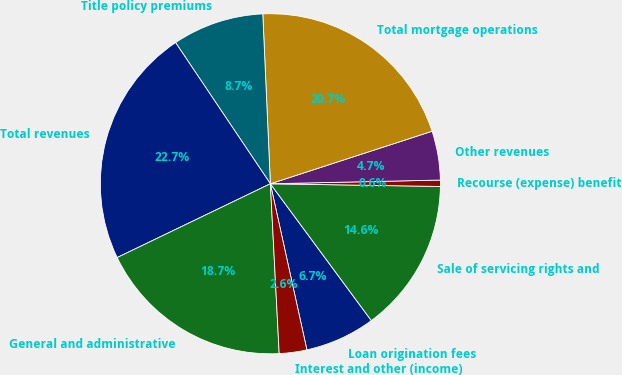Convert chart. <chart><loc_0><loc_0><loc_500><loc_500><pie_chart><fcel>Loan origination fees<fcel>Sale of servicing rights and<fcel>Recourse (expense) benefit<fcel>Other revenues<fcel>Total mortgage operations<fcel>Title policy premiums<fcel>Total revenues<fcel>General and administrative<fcel>Interest and other (income)<nl><fcel>6.67%<fcel>14.63%<fcel>0.6%<fcel>4.65%<fcel>20.71%<fcel>8.7%<fcel>22.73%<fcel>18.68%<fcel>2.62%<nl></chart> 